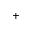<formula> <loc_0><loc_0><loc_500><loc_500>^ { + }</formula> 